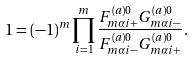<formula> <loc_0><loc_0><loc_500><loc_500>1 = ( - 1 ) ^ { m } \prod _ { i = 1 } ^ { m } \frac { F ^ { ( a ) 0 } _ { m \alpha i + } G ^ { ( a ) 0 } _ { m \alpha i - } } { F ^ { ( a ) 0 } _ { m \alpha i - } G ^ { ( a ) 0 } _ { m \alpha i + } } .</formula> 